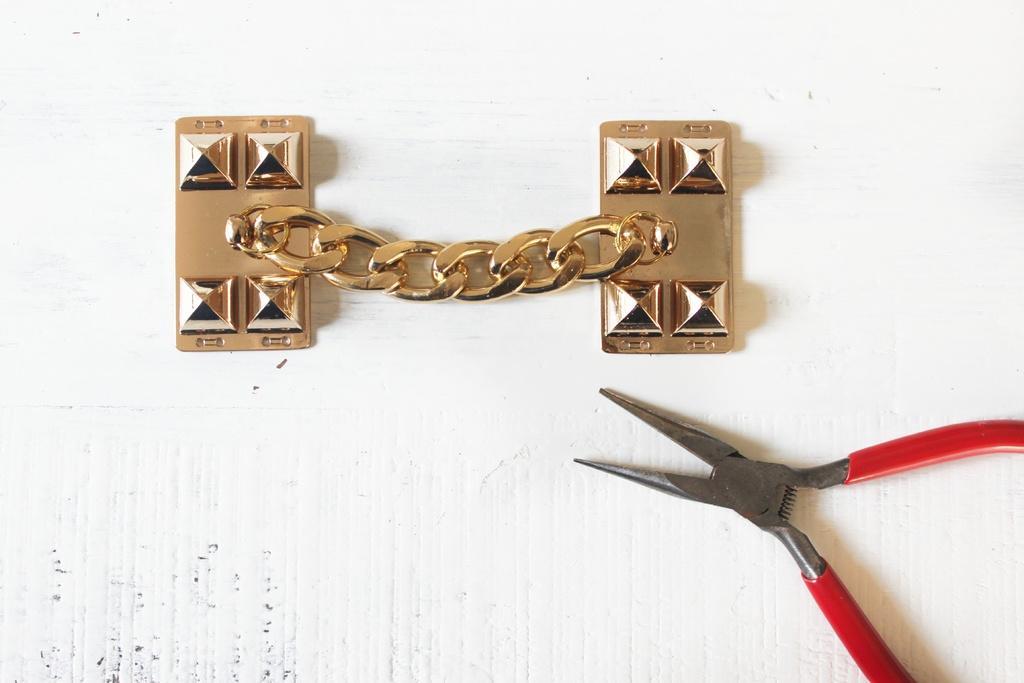Can you describe this image briefly? In this picture there is a metal object and there is a tool. At the back it looks like a wall. 